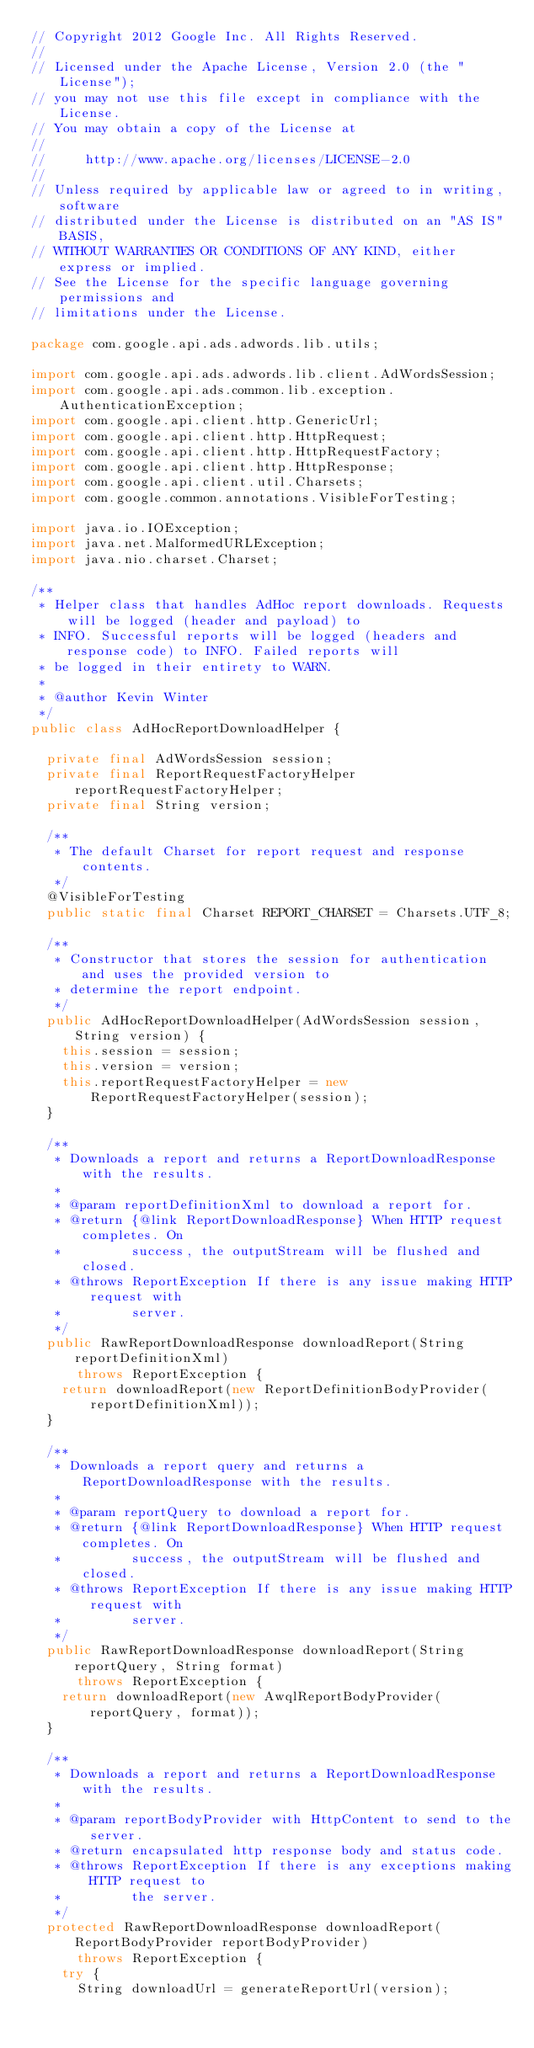<code> <loc_0><loc_0><loc_500><loc_500><_Java_>// Copyright 2012 Google Inc. All Rights Reserved.
//
// Licensed under the Apache License, Version 2.0 (the "License");
// you may not use this file except in compliance with the License.
// You may obtain a copy of the License at
//
//     http://www.apache.org/licenses/LICENSE-2.0
//
// Unless required by applicable law or agreed to in writing, software
// distributed under the License is distributed on an "AS IS" BASIS,
// WITHOUT WARRANTIES OR CONDITIONS OF ANY KIND, either express or implied.
// See the License for the specific language governing permissions and
// limitations under the License.

package com.google.api.ads.adwords.lib.utils;

import com.google.api.ads.adwords.lib.client.AdWordsSession;
import com.google.api.ads.common.lib.exception.AuthenticationException;
import com.google.api.client.http.GenericUrl;
import com.google.api.client.http.HttpRequest;
import com.google.api.client.http.HttpRequestFactory;
import com.google.api.client.http.HttpResponse;
import com.google.api.client.util.Charsets;
import com.google.common.annotations.VisibleForTesting;

import java.io.IOException;
import java.net.MalformedURLException;
import java.nio.charset.Charset;

/**
 * Helper class that handles AdHoc report downloads. Requests will be logged (header and payload) to
 * INFO. Successful reports will be logged (headers and response code) to INFO. Failed reports will
 * be logged in their entirety to WARN.
 *
 * @author Kevin Winter
 */
public class AdHocReportDownloadHelper {

  private final AdWordsSession session;
  private final ReportRequestFactoryHelper reportRequestFactoryHelper;
  private final String version;

  /**
   * The default Charset for report request and response contents.
   */
  @VisibleForTesting
  public static final Charset REPORT_CHARSET = Charsets.UTF_8;
  
  /**
   * Constructor that stores the session for authentication and uses the provided version to
   * determine the report endpoint.
   */
  public AdHocReportDownloadHelper(AdWordsSession session, String version) {
    this.session = session;
    this.version = version;
    this.reportRequestFactoryHelper = new ReportRequestFactoryHelper(session);
  }

  /**
   * Downloads a report and returns a ReportDownloadResponse with the results.
   *
   * @param reportDefinitionXml to download a report for.
   * @return {@link ReportDownloadResponse} When HTTP request completes. On
   *         success, the outputStream will be flushed and closed.
   * @throws ReportException If there is any issue making HTTP request with
   *         server.
   */
  public RawReportDownloadResponse downloadReport(String reportDefinitionXml)
      throws ReportException {
    return downloadReport(new ReportDefinitionBodyProvider(reportDefinitionXml));
  }

  /**
   * Downloads a report query and returns a ReportDownloadResponse with the results.
   *
   * @param reportQuery to download a report for.
   * @return {@link ReportDownloadResponse} When HTTP request completes. On
   *         success, the outputStream will be flushed and closed.
   * @throws ReportException If there is any issue making HTTP request with
   *         server.
   */
  public RawReportDownloadResponse downloadReport(String reportQuery, String format)
      throws ReportException {
    return downloadReport(new AwqlReportBodyProvider(reportQuery, format));
  }

  /**
   * Downloads a report and returns a ReportDownloadResponse with the results.
   *
   * @param reportBodyProvider with HttpContent to send to the server.
   * @return encapsulated http response body and status code.
   * @throws ReportException If there is any exceptions making HTTP request to
   *         the server.
   */
  protected RawReportDownloadResponse downloadReport(ReportBodyProvider reportBodyProvider)
      throws ReportException {
    try {
      String downloadUrl = generateReportUrl(version);</code> 